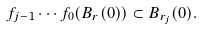<formula> <loc_0><loc_0><loc_500><loc_500>f _ { j - 1 } \cdots f _ { 0 } ( B _ { r } ( 0 ) ) \subset B _ { r _ { j } } ( 0 ) .</formula> 